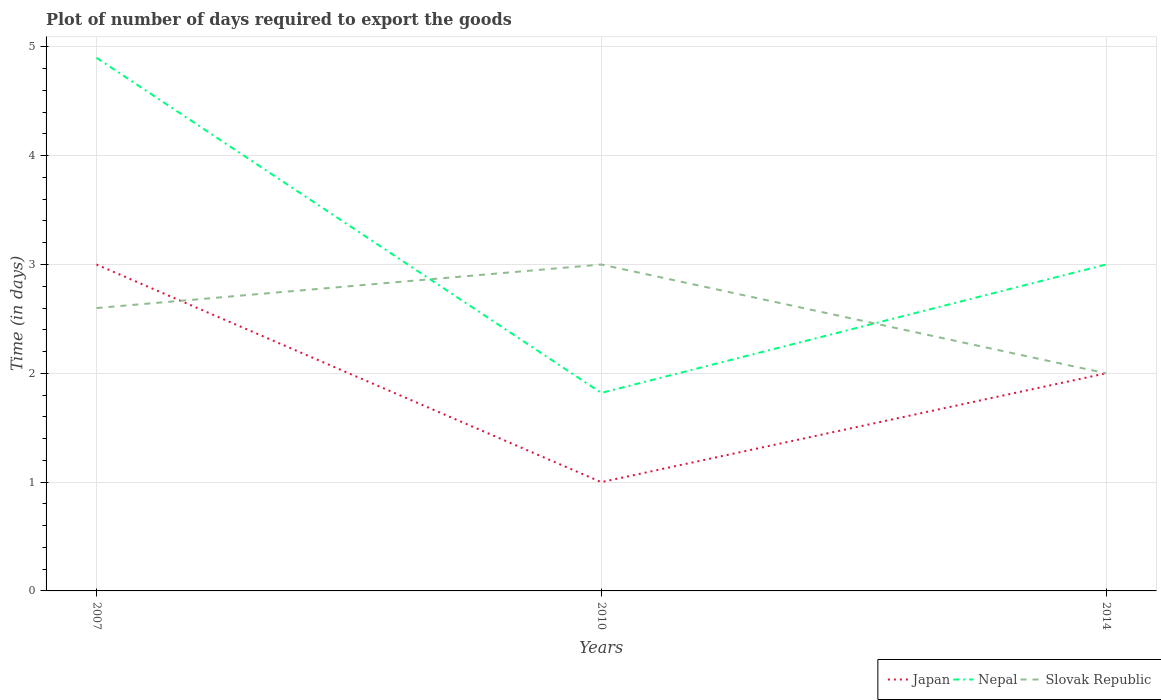Does the line corresponding to Slovak Republic intersect with the line corresponding to Nepal?
Offer a very short reply. Yes. Across all years, what is the maximum time required to export goods in Nepal?
Offer a very short reply. 1.82. What is the total time required to export goods in Slovak Republic in the graph?
Provide a succinct answer. 1. What is the difference between the highest and the second highest time required to export goods in Japan?
Offer a terse response. 2. What is the difference between the highest and the lowest time required to export goods in Japan?
Keep it short and to the point. 1. How many lines are there?
Your answer should be compact. 3. Does the graph contain any zero values?
Your response must be concise. No. Does the graph contain grids?
Your response must be concise. Yes. Where does the legend appear in the graph?
Ensure brevity in your answer.  Bottom right. How many legend labels are there?
Your answer should be compact. 3. What is the title of the graph?
Give a very brief answer. Plot of number of days required to export the goods. What is the label or title of the X-axis?
Provide a short and direct response. Years. What is the label or title of the Y-axis?
Your answer should be compact. Time (in days). What is the Time (in days) in Nepal in 2007?
Provide a succinct answer. 4.9. What is the Time (in days) of Nepal in 2010?
Provide a short and direct response. 1.82. Across all years, what is the maximum Time (in days) in Japan?
Provide a short and direct response. 3. Across all years, what is the maximum Time (in days) of Nepal?
Your answer should be very brief. 4.9. Across all years, what is the minimum Time (in days) in Nepal?
Keep it short and to the point. 1.82. Across all years, what is the minimum Time (in days) in Slovak Republic?
Offer a terse response. 2. What is the total Time (in days) in Nepal in the graph?
Provide a short and direct response. 9.72. What is the total Time (in days) of Slovak Republic in the graph?
Make the answer very short. 7.6. What is the difference between the Time (in days) in Nepal in 2007 and that in 2010?
Ensure brevity in your answer.  3.08. What is the difference between the Time (in days) in Slovak Republic in 2007 and that in 2010?
Provide a succinct answer. -0.4. What is the difference between the Time (in days) of Japan in 2007 and that in 2014?
Your answer should be very brief. 1. What is the difference between the Time (in days) in Slovak Republic in 2007 and that in 2014?
Give a very brief answer. 0.6. What is the difference between the Time (in days) in Japan in 2010 and that in 2014?
Make the answer very short. -1. What is the difference between the Time (in days) of Nepal in 2010 and that in 2014?
Offer a terse response. -1.18. What is the difference between the Time (in days) in Japan in 2007 and the Time (in days) in Nepal in 2010?
Offer a terse response. 1.18. What is the difference between the Time (in days) of Japan in 2007 and the Time (in days) of Slovak Republic in 2010?
Provide a succinct answer. 0. What is the difference between the Time (in days) in Nepal in 2007 and the Time (in days) in Slovak Republic in 2010?
Ensure brevity in your answer.  1.9. What is the difference between the Time (in days) of Japan in 2007 and the Time (in days) of Nepal in 2014?
Provide a short and direct response. 0. What is the difference between the Time (in days) in Japan in 2010 and the Time (in days) in Nepal in 2014?
Ensure brevity in your answer.  -2. What is the difference between the Time (in days) in Nepal in 2010 and the Time (in days) in Slovak Republic in 2014?
Your answer should be compact. -0.18. What is the average Time (in days) of Nepal per year?
Make the answer very short. 3.24. What is the average Time (in days) in Slovak Republic per year?
Give a very brief answer. 2.53. In the year 2010, what is the difference between the Time (in days) in Japan and Time (in days) in Nepal?
Your answer should be very brief. -0.82. In the year 2010, what is the difference between the Time (in days) of Japan and Time (in days) of Slovak Republic?
Your answer should be compact. -2. In the year 2010, what is the difference between the Time (in days) in Nepal and Time (in days) in Slovak Republic?
Offer a terse response. -1.18. In the year 2014, what is the difference between the Time (in days) of Japan and Time (in days) of Nepal?
Your response must be concise. -1. In the year 2014, what is the difference between the Time (in days) of Japan and Time (in days) of Slovak Republic?
Provide a succinct answer. 0. What is the ratio of the Time (in days) in Japan in 2007 to that in 2010?
Give a very brief answer. 3. What is the ratio of the Time (in days) of Nepal in 2007 to that in 2010?
Your response must be concise. 2.69. What is the ratio of the Time (in days) of Slovak Republic in 2007 to that in 2010?
Provide a short and direct response. 0.87. What is the ratio of the Time (in days) in Japan in 2007 to that in 2014?
Offer a terse response. 1.5. What is the ratio of the Time (in days) of Nepal in 2007 to that in 2014?
Offer a very short reply. 1.63. What is the ratio of the Time (in days) of Slovak Republic in 2007 to that in 2014?
Your answer should be compact. 1.3. What is the ratio of the Time (in days) in Japan in 2010 to that in 2014?
Keep it short and to the point. 0.5. What is the ratio of the Time (in days) of Nepal in 2010 to that in 2014?
Your response must be concise. 0.61. What is the difference between the highest and the second highest Time (in days) in Japan?
Give a very brief answer. 1. What is the difference between the highest and the second highest Time (in days) of Slovak Republic?
Offer a terse response. 0.4. What is the difference between the highest and the lowest Time (in days) in Japan?
Keep it short and to the point. 2. What is the difference between the highest and the lowest Time (in days) of Nepal?
Your answer should be compact. 3.08. 